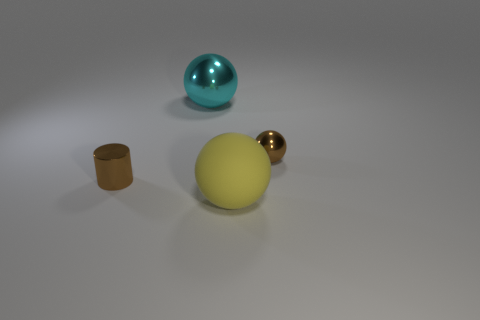Is there anything else that has the same material as the big yellow ball?
Your answer should be very brief. No. What color is the other large metal object that is the same shape as the yellow thing?
Keep it short and to the point. Cyan. What number of things are either cyan spheres or balls that are behind the small metallic ball?
Your answer should be compact. 1. Are there fewer big yellow spheres to the right of the large yellow rubber sphere than brown metal objects?
Provide a short and direct response. Yes. What size is the sphere behind the brown shiny thing behind the metallic thing in front of the brown sphere?
Give a very brief answer. Large. What color is the metal thing that is both on the left side of the big yellow sphere and behind the small brown metal cylinder?
Provide a succinct answer. Cyan. What number of large metal balls are there?
Give a very brief answer. 1. Is there any other thing that is the same size as the brown metal sphere?
Offer a very short reply. Yes. Does the tiny brown cylinder have the same material as the big yellow sphere?
Your response must be concise. No. Is the size of the object that is left of the big cyan thing the same as the brown metallic thing on the right side of the big yellow ball?
Offer a terse response. Yes. 